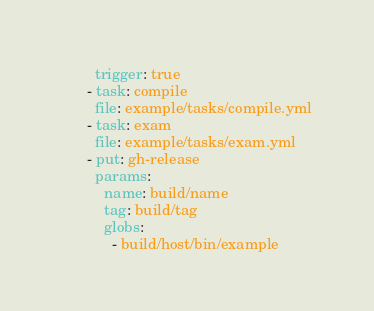<code> <loc_0><loc_0><loc_500><loc_500><_YAML_>        trigger: true
      - task: compile
        file: example/tasks/compile.yml
      - task: exam
        file: example/tasks/exam.yml
      - put: gh-release
        params:
          name: build/name
          tag: build/tag
          globs:
            - build/host/bin/example
</code> 